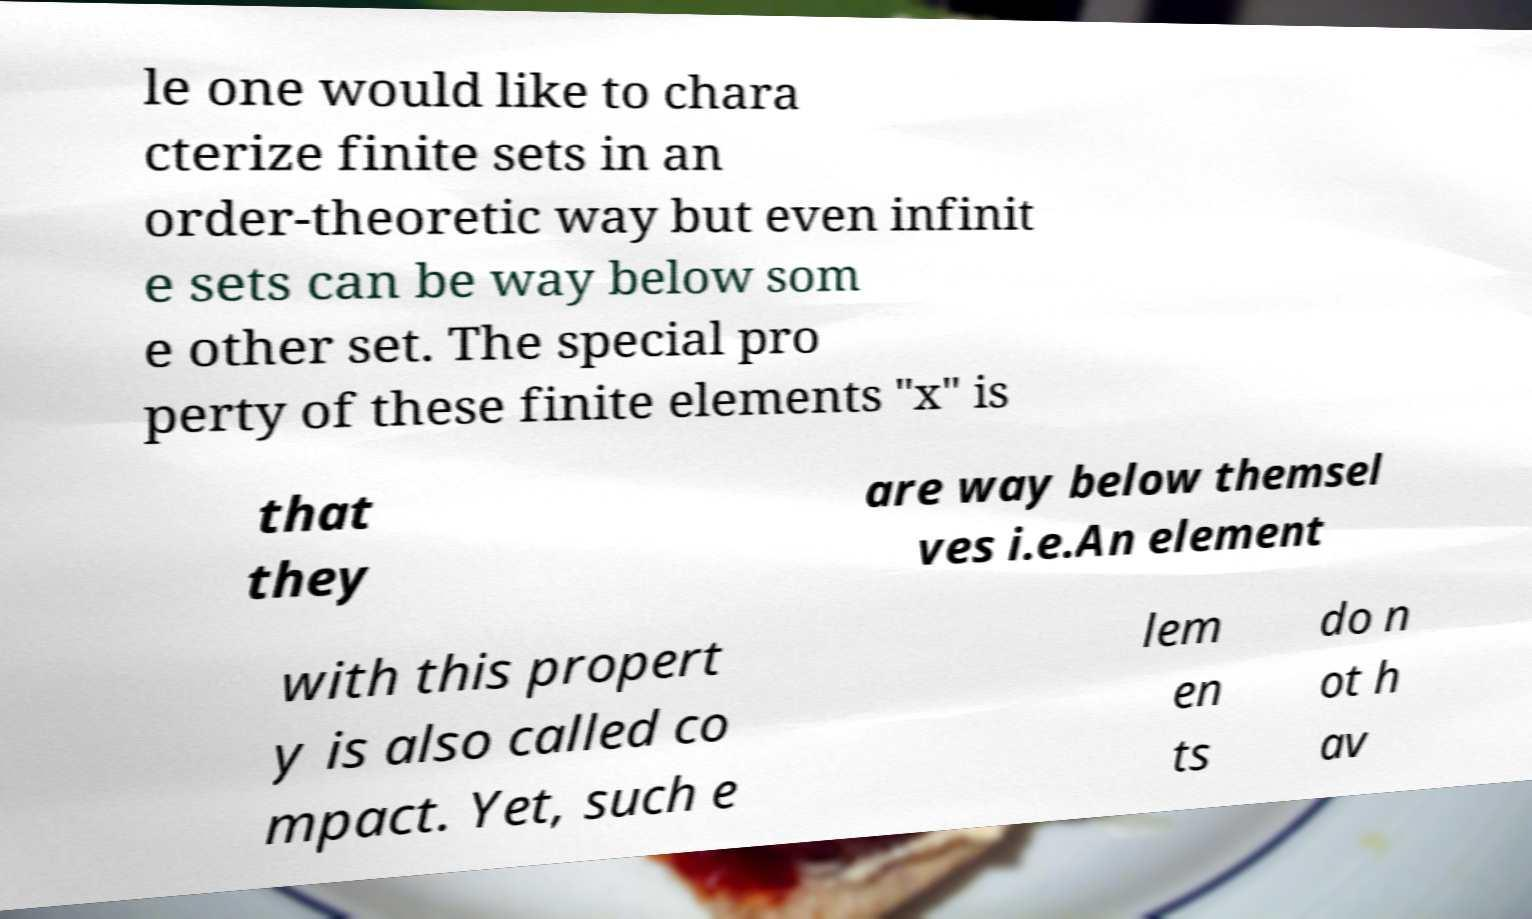Can you read and provide the text displayed in the image?This photo seems to have some interesting text. Can you extract and type it out for me? le one would like to chara cterize finite sets in an order-theoretic way but even infinit e sets can be way below som e other set. The special pro perty of these finite elements "x" is that they are way below themsel ves i.e.An element with this propert y is also called co mpact. Yet, such e lem en ts do n ot h av 